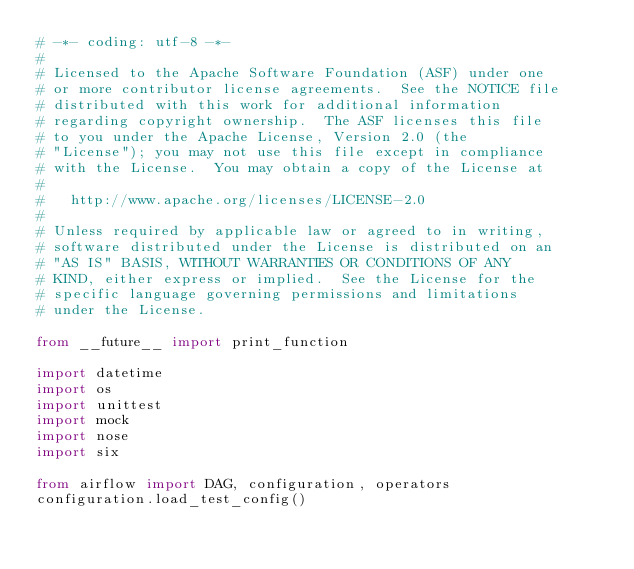<code> <loc_0><loc_0><loc_500><loc_500><_Python_># -*- coding: utf-8 -*-
#
# Licensed to the Apache Software Foundation (ASF) under one
# or more contributor license agreements.  See the NOTICE file
# distributed with this work for additional information
# regarding copyright ownership.  The ASF licenses this file
# to you under the Apache License, Version 2.0 (the
# "License"); you may not use this file except in compliance
# with the License.  You may obtain a copy of the License at
# 
#   http://www.apache.org/licenses/LICENSE-2.0
# 
# Unless required by applicable law or agreed to in writing,
# software distributed under the License is distributed on an
# "AS IS" BASIS, WITHOUT WARRANTIES OR CONDITIONS OF ANY
# KIND, either express or implied.  See the License for the
# specific language governing permissions and limitations
# under the License.

from __future__ import print_function

import datetime
import os
import unittest
import mock
import nose
import six

from airflow import DAG, configuration, operators
configuration.load_test_config()

</code> 